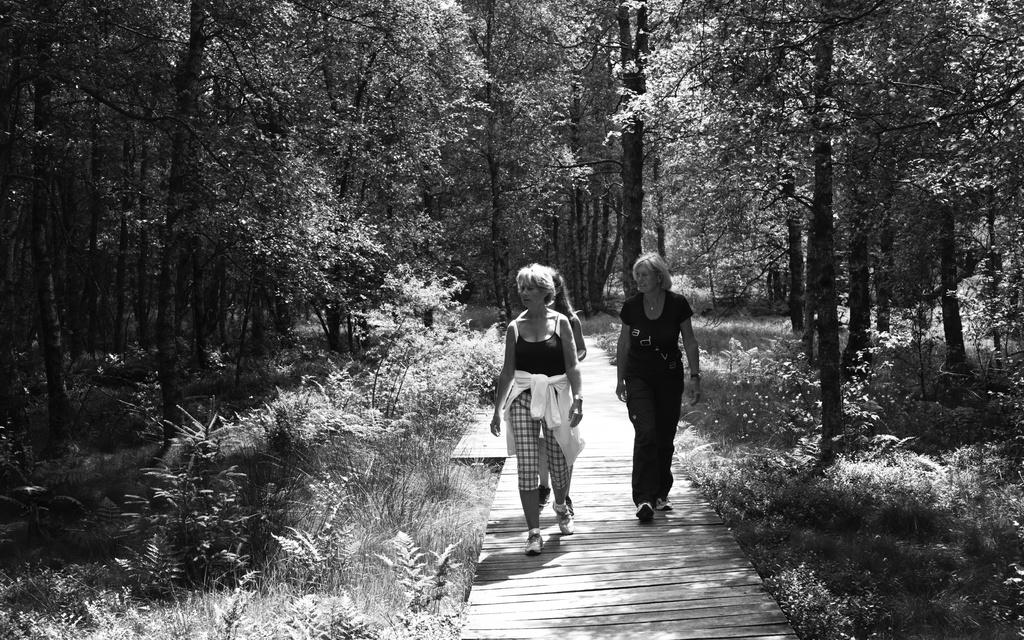What is the color scheme of the image? The image is black and white. How many women are present in the image? There are three women in the image. What are the women doing in the image? The women are walking on a wooden bridge. What can be seen on either side of the bridge? There are plants and trees on either side of the bridge. What type of sponge can be seen floating in the river beneath the bridge? There is no sponge visible in the image, and the image does not depict a river beneath the bridge. 